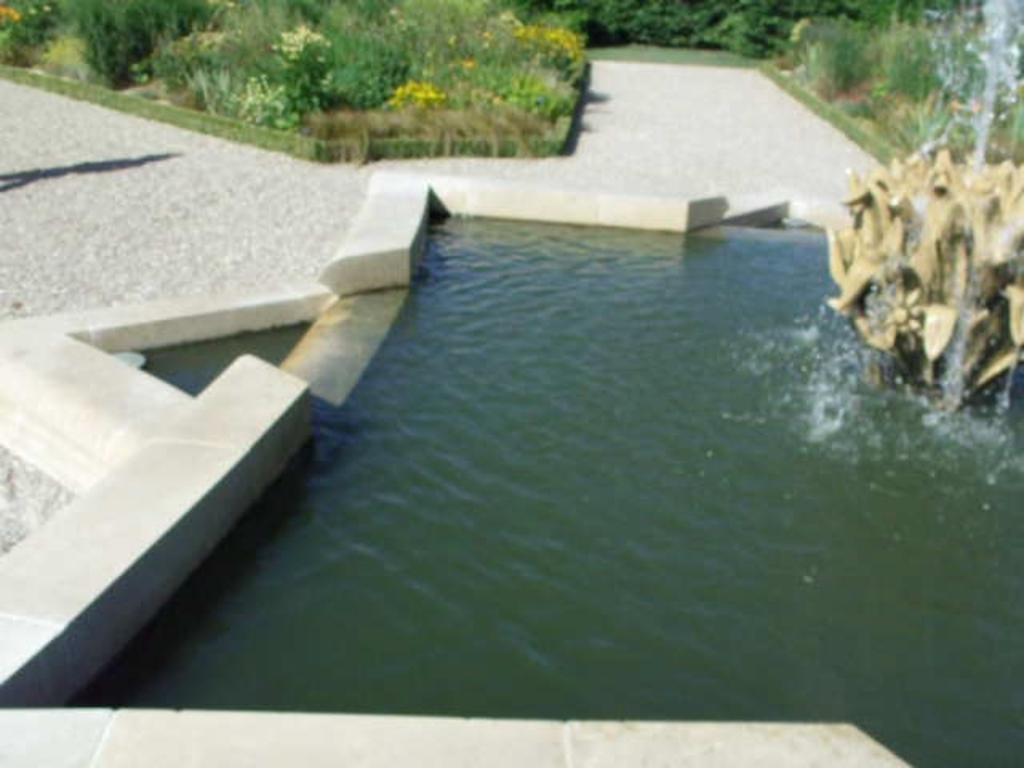What is the main feature in the image? There is a fountain in the image. What can be seen near the fountain? There are plants beside the path in the image. How much rice is being served to the visitor in the image? There is no rice or visitor present in the image; it features a fountain and plants beside a path. 